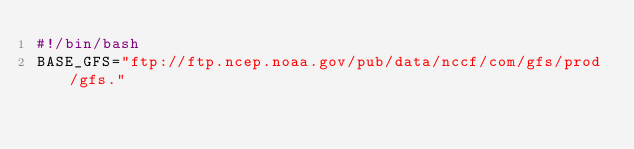<code> <loc_0><loc_0><loc_500><loc_500><_Bash_>#!/bin/bash 
BASE_GFS="ftp://ftp.ncep.noaa.gov/pub/data/nccf/com/gfs/prod/gfs."</code> 